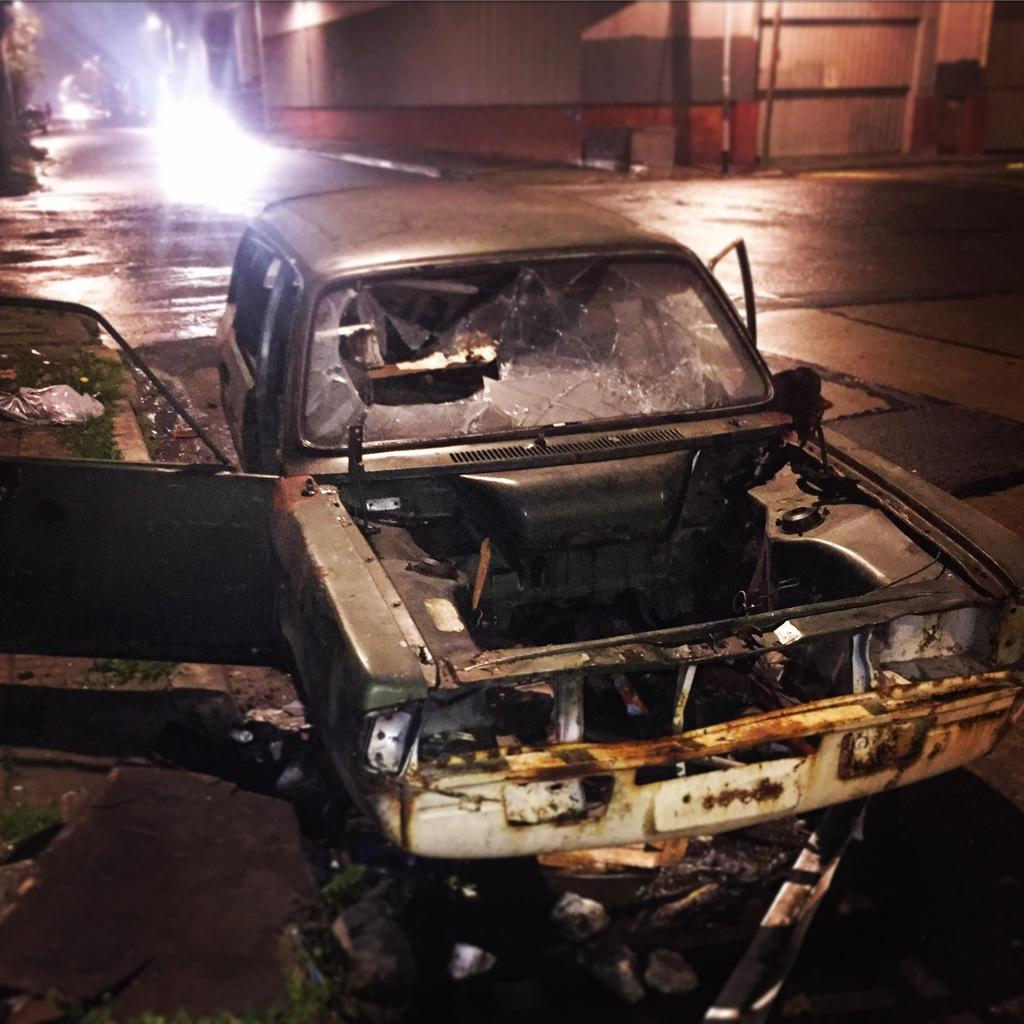What is the condition of the car in the image? There is a damaged car in the image. What is located behind the damaged car? There is a fence wall behind the damaged car. Is the damaged car emitting steam in the image? No, the damaged car is not emitting steam in the image. What type of emotion is being expressed by the damaged car in the image? Cars do not express emotions, so this question cannot be answered definitively from the image. 